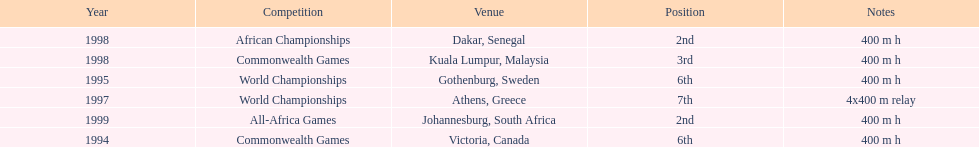In what years did ken harnden do better that 5th place? 1998, 1999. 